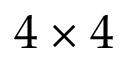<formula> <loc_0><loc_0><loc_500><loc_500>4 \times 4</formula> 